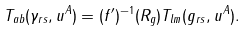Convert formula to latex. <formula><loc_0><loc_0><loc_500><loc_500>T _ { a b } ( \gamma _ { r s } , u ^ { A } ) = ( f ^ { \prime } ) ^ { - 1 } ( R _ { g } ) T _ { l m } ( g _ { r s } , u ^ { A } ) .</formula> 